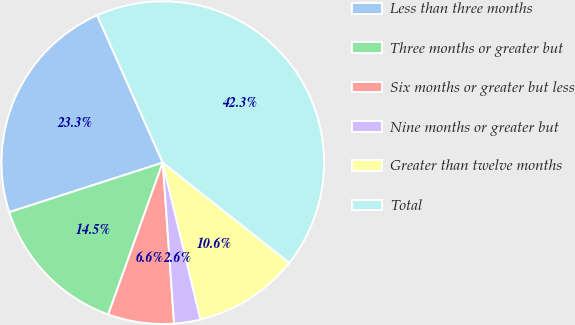Convert chart to OTSL. <chart><loc_0><loc_0><loc_500><loc_500><pie_chart><fcel>Less than three months<fcel>Three months or greater but<fcel>Six months or greater but less<fcel>Nine months or greater but<fcel>Greater than twelve months<fcel>Total<nl><fcel>23.31%<fcel>14.54%<fcel>6.61%<fcel>2.64%<fcel>10.58%<fcel>42.33%<nl></chart> 